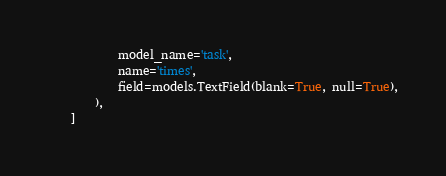<code> <loc_0><loc_0><loc_500><loc_500><_Python_>            model_name='task',
            name='times',
            field=models.TextField(blank=True, null=True),
        ),
    ]
</code> 